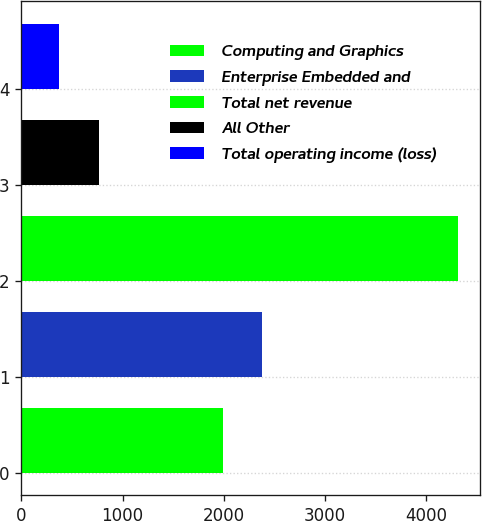Convert chart to OTSL. <chart><loc_0><loc_0><loc_500><loc_500><bar_chart><fcel>Computing and Graphics<fcel>Enterprise Embedded and<fcel>Total net revenue<fcel>All Other<fcel>Total operating income (loss)<nl><fcel>1988<fcel>2382.6<fcel>4319<fcel>767.6<fcel>373<nl></chart> 